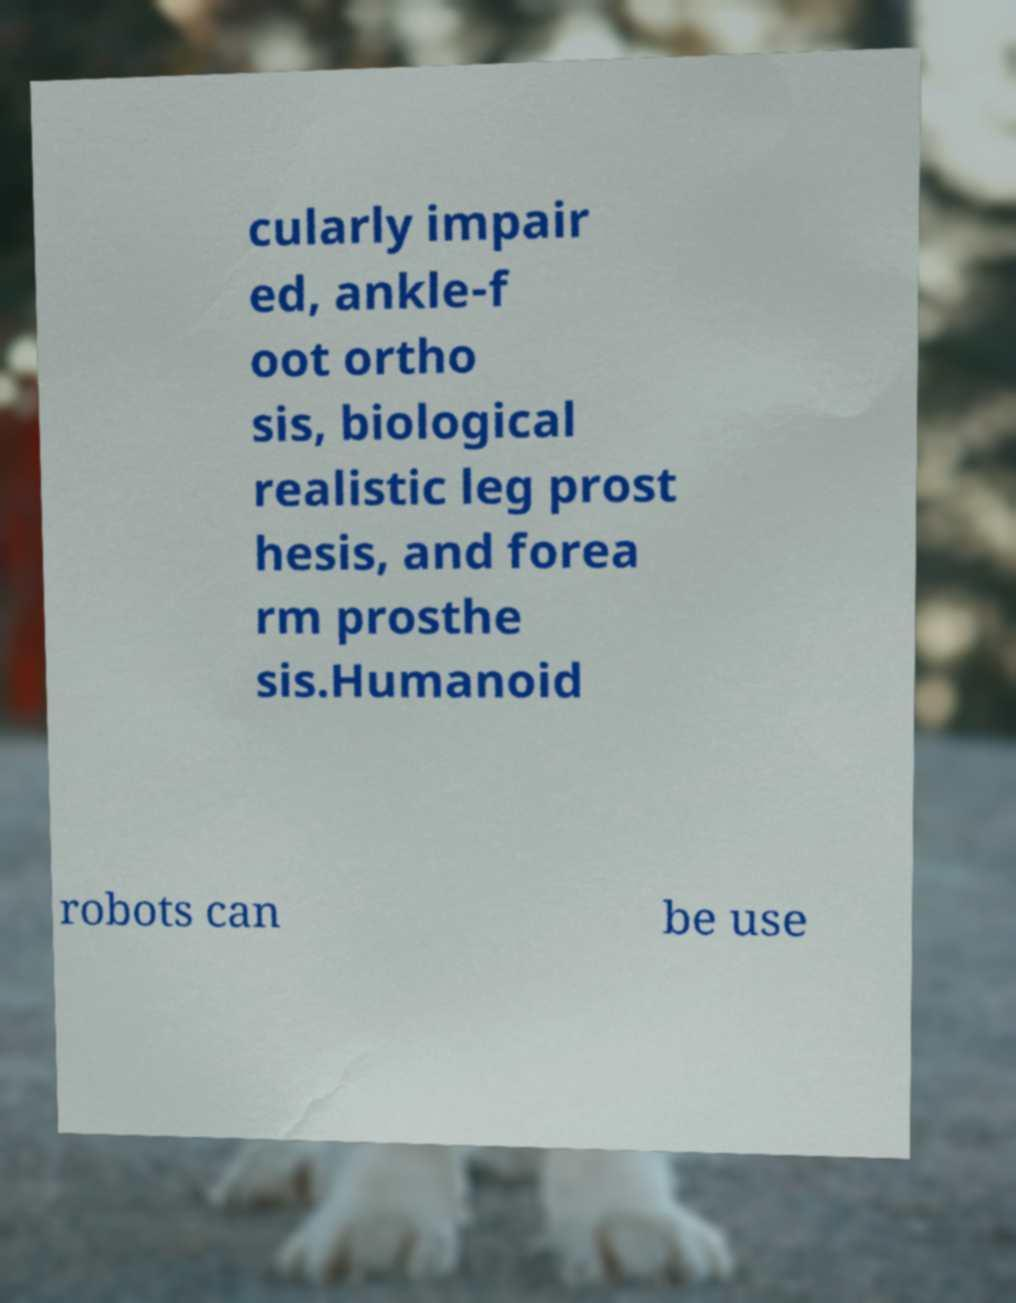I need the written content from this picture converted into text. Can you do that? cularly impair ed, ankle-f oot ortho sis, biological realistic leg prost hesis, and forea rm prosthe sis.Humanoid robots can be use 